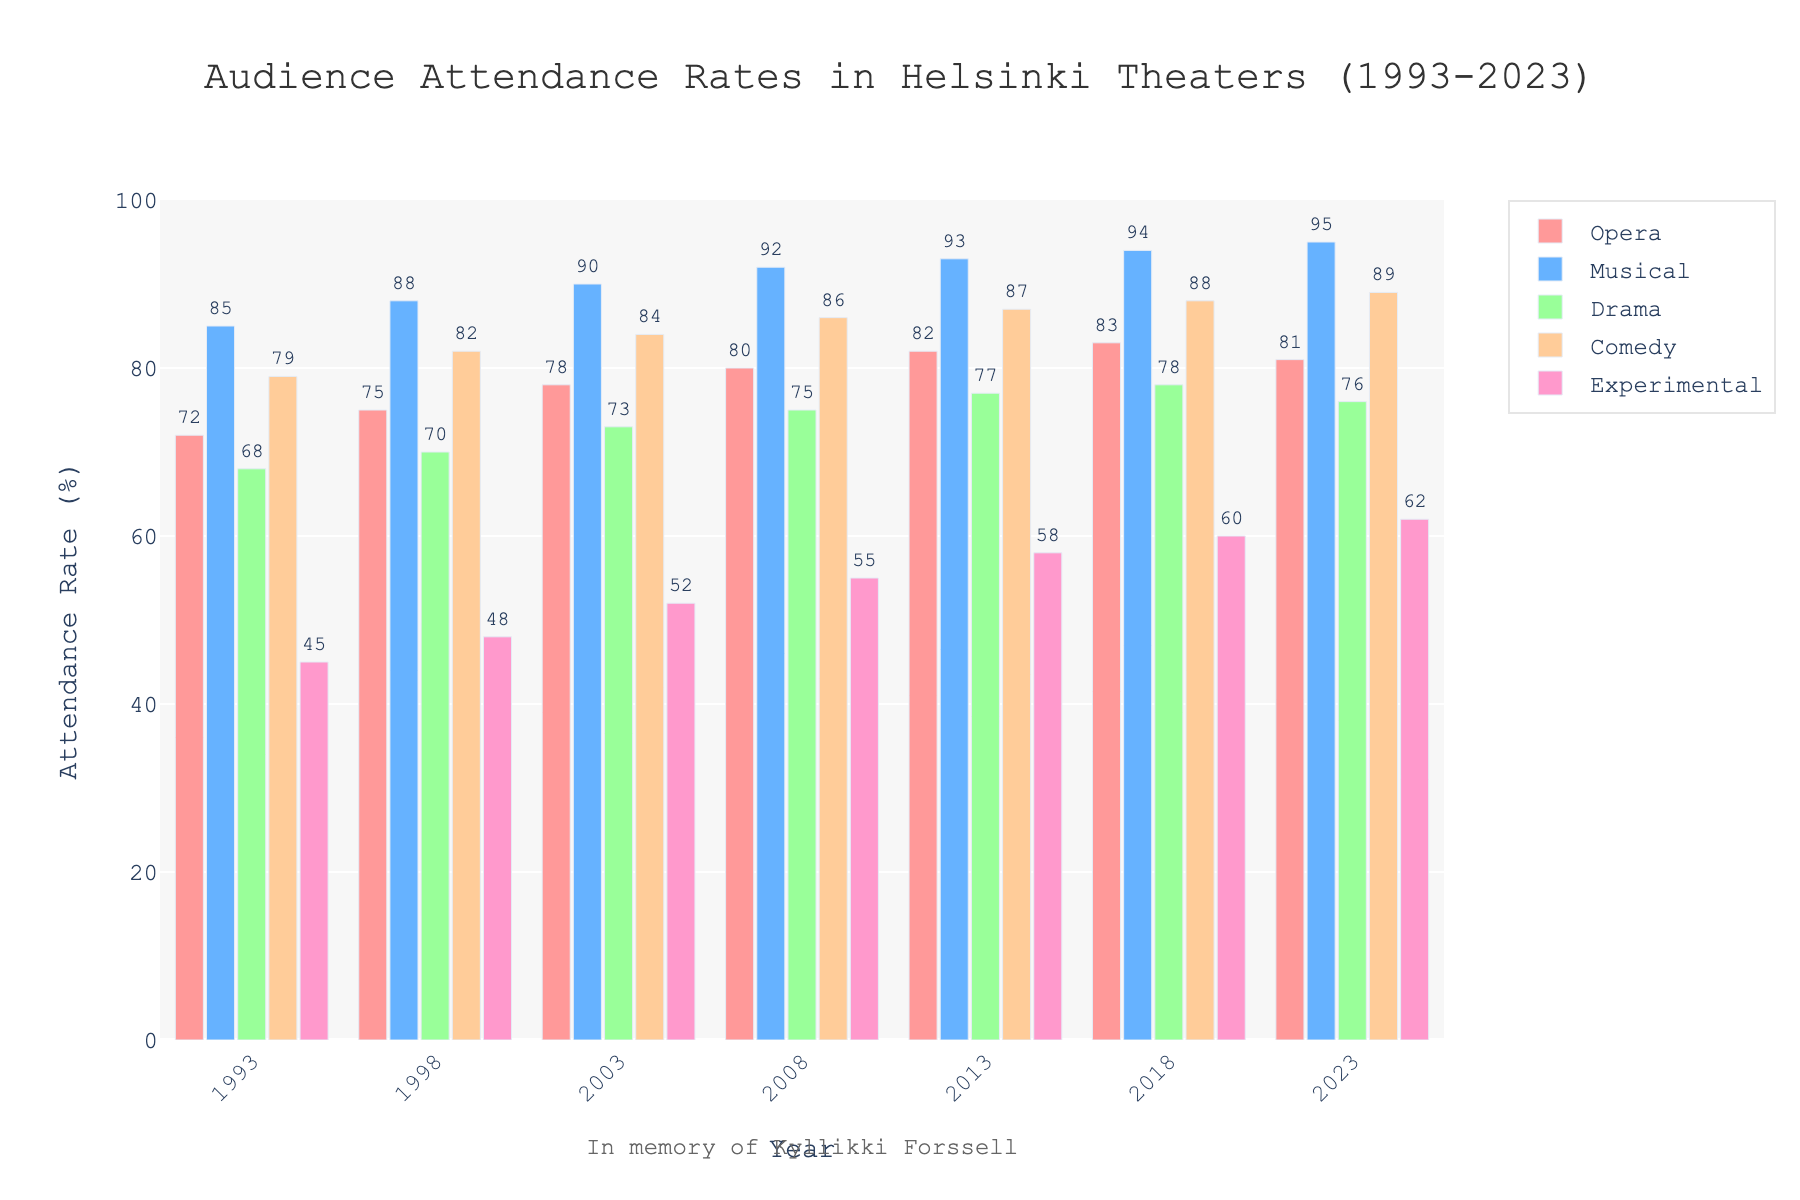What is the overall trend in attendance rates for Musicals over the 30-year period? The attendance rate for Musicals steadily increases from 85% in 1993 to 95% in 2023. This indicates a growing popularity of musicals over the period.
Answer: Steadily increases Which type of performance had the lowest attendance rate in 1993? In 1993, Experimental performances had the lowest attendance rate at 45%, which is visually the smallest bar in that year.
Answer: Experimental How does the attendance rate for Comedies in 2013 compare to that in 2008? The attendance rate for Comedies in 2013 was 87%, while in 2008 it was 86%. So, it increased by 1%.
Answer: Increased by 1% Out of Drama and Opera, which had a higher attendance rate in 2018, and by how much? In 2018, Drama had a 78% attendance rate, while Opera had 83%. Opera's attendance rate was higher by 5%.
Answer: Opera, by 5% What is the average attendance rate for Experimental performances across all the years? Sum the attendance rates for Experimental performances across all years and divide by the number of years: (45 + 48 + 52 + 55 + 58 + 60 + 62) / 7 = 380 / 7 ≈ 54.29%
Answer: ≈ 54.29% Which performance type shows the least fluctuation in attendance rates over the years? By observing the bar heights for each category, Musicals show the least fluctuation with attendance rates gradually increasing from 85% to 95% over 30 years.
Answer: Musicals Considering all years, which performance type had the highest single attendance rate in the entire dataset? The highest single attendance rate in the dataset is for Musicals in 2023, at 95%.
Answer: Musicals in 2023 Between 1993 and 2023, what year saw the highest attendance rate for Dramas, and what was that rate? The highest attendance rate for Dramas was in 2018, with a rate of 78%.
Answer: 2018, 78% If the attendance rate for Comedies in 1998 increased by 5%, what would it be? The attendance rate for Comedies in 1998 was 82%. If increased by 5%, it would be: 82% + 5% = 87%
Answer: 87% Among all categories, what is the second highest attendance rate recorded in 2013? In 2013, the attendance rates are as follows: Opera (82%), Musical (93%), Drama (77%), Comedy (87%), and Experimental (58%). The second highest rate is for Comedies at 87%.
Answer: 87% 